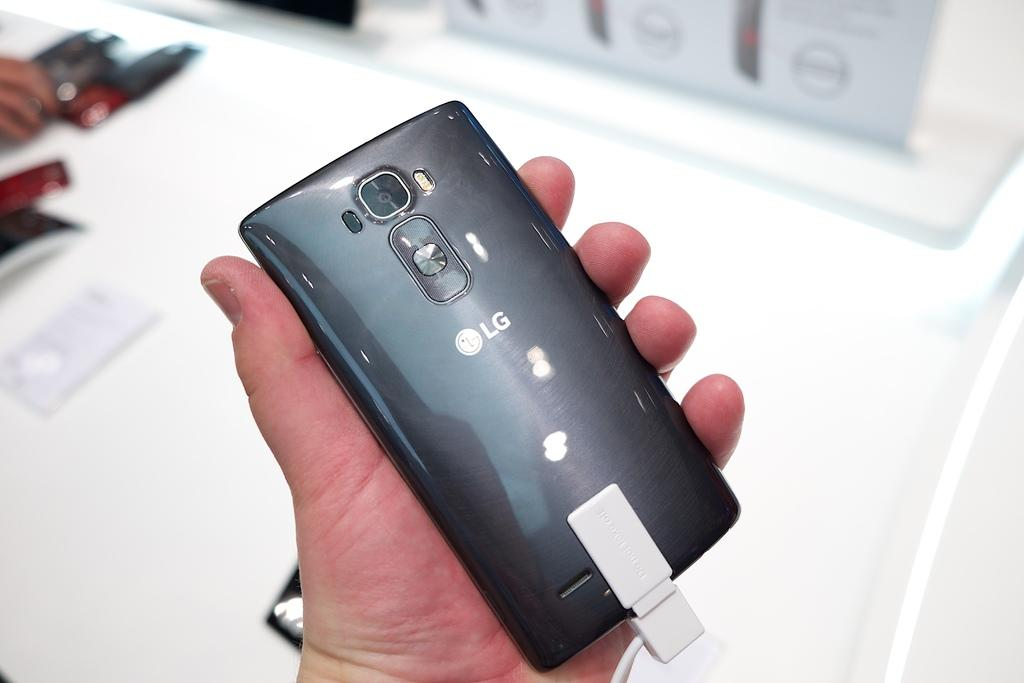<image>
Create a compact narrative representing the image presented. The reverse of an LG phone where we can see the camera lens. 